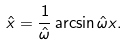Convert formula to latex. <formula><loc_0><loc_0><loc_500><loc_500>\hat { x } = \frac { 1 } { \hat { \omega } } \arcsin \hat { \omega } x .</formula> 